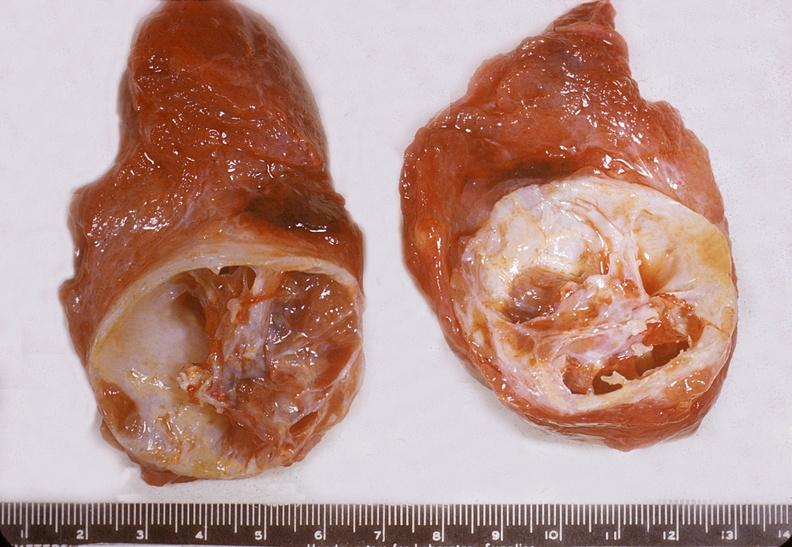how does this image show thyroid, nodular colloid goiter?
Answer the question using a single word or phrase. With cystic degeneration 